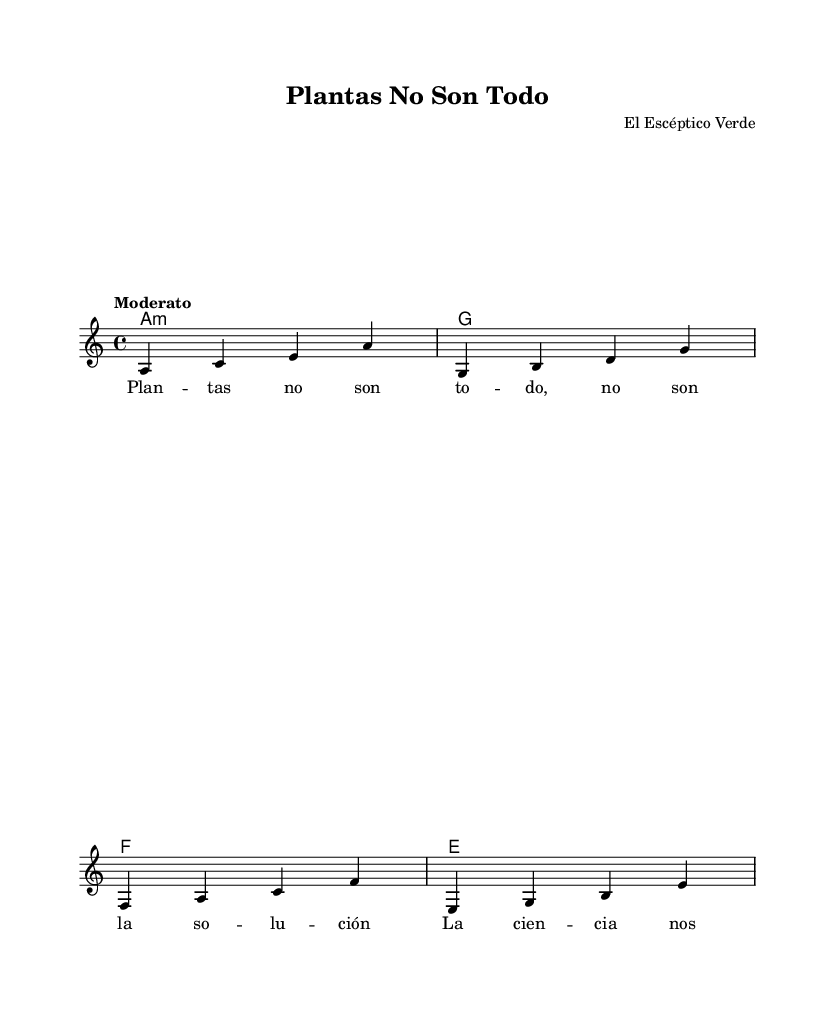What is the key signature of this music? The key signature indicated in the music sheet is A minor, which has no sharps or flats.
Answer: A minor What is the time signature of this piece? The time signature displayed in the music sheet is 4/4, which means there are four beats in each measure.
Answer: 4/4 What is the tempo marking for this piece? The tempo marking provided in the sheet music is "Moderato," indicating a moderate pace for the music being played.
Answer: Moderato How many measures are in the melody? The melody contains four measures, as each segment separated by vertical lines represents one measure.
Answer: 4 What is the stanza structure of the lyrics? The lyrics have a stanza structure that consists of two lines, which each represent a verse in the song.
Answer: 2 lines What do the lyrics suggest is not the solution? The lyrics suggest that plants are not the complete solution to dietary needs and emphasize a different perspective based on science.
Answer: Not the solution What is the composer's name? The composer listed in the header of the music sheet is "El Escéptico Verde," indicating the identity of the creator of the song.
Answer: El Escéptico Verde 